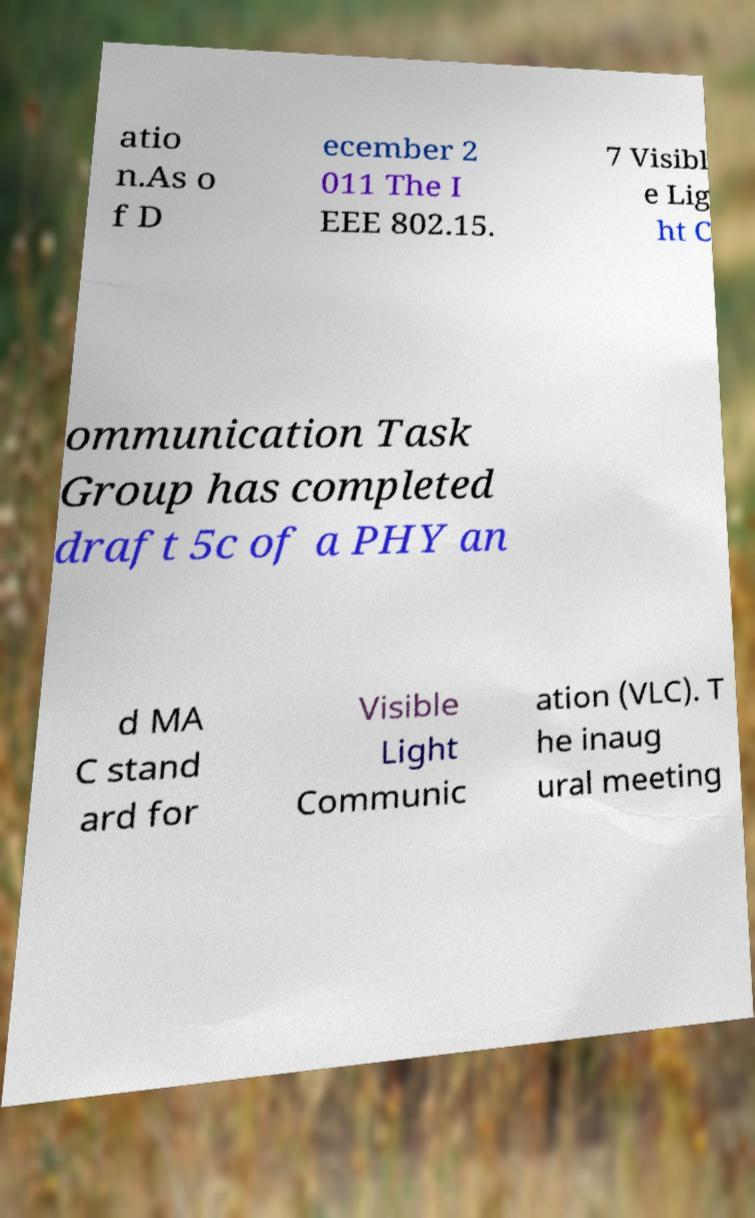I need the written content from this picture converted into text. Can you do that? atio n.As o f D ecember 2 011 The I EEE 802.15. 7 Visibl e Lig ht C ommunication Task Group has completed draft 5c of a PHY an d MA C stand ard for Visible Light Communic ation (VLC). T he inaug ural meeting 